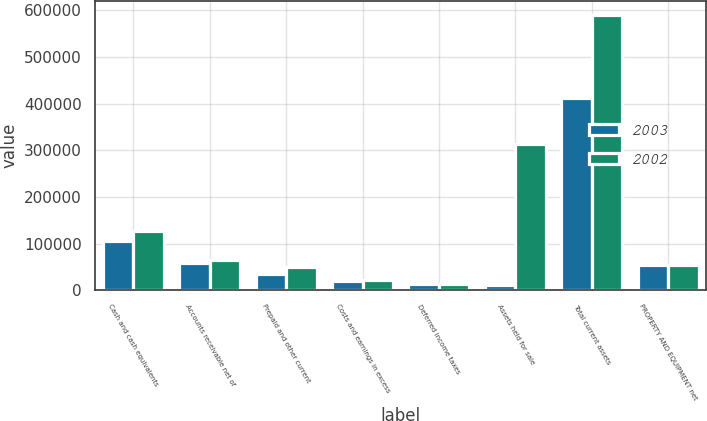<chart> <loc_0><loc_0><loc_500><loc_500><stacked_bar_chart><ecel><fcel>Cash and cash equivalents<fcel>Accounts receivable net of<fcel>Prepaid and other current<fcel>Costs and earnings in excess<fcel>Deferred income taxes<fcel>Assets held for sale<fcel>Total current assets<fcel>PROPERTY AND EQUIPMENT net<nl><fcel>2003<fcel>105465<fcel>57735<fcel>34105<fcel>19933<fcel>14122<fcel>10119<fcel>411515<fcel>53529.5<nl><fcel>2002<fcel>127292<fcel>64889<fcel>49324<fcel>21955<fcel>13111<fcel>314205<fcel>590776<fcel>53529.5<nl></chart> 